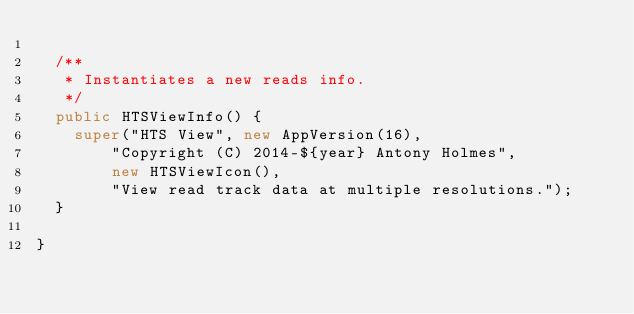Convert code to text. <code><loc_0><loc_0><loc_500><loc_500><_Java_>
  /**
   * Instantiates a new reads info.
   */
  public HTSViewInfo() {
    super("HTS View", new AppVersion(16),
        "Copyright (C) 2014-${year} Antony Holmes",
        new HTSViewIcon(),
        "View read track data at multiple resolutions.");
  }

}
</code> 